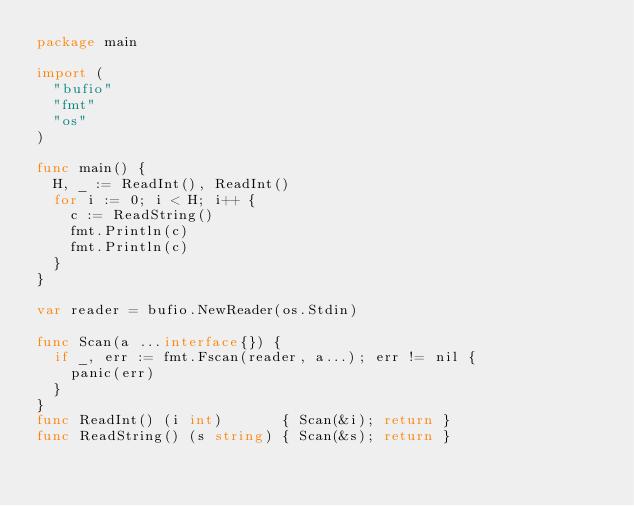<code> <loc_0><loc_0><loc_500><loc_500><_Go_>package main

import (
	"bufio"
	"fmt"
	"os"
)

func main() {
	H, _ := ReadInt(), ReadInt()
	for i := 0; i < H; i++ {
		c := ReadString()
		fmt.Println(c)
		fmt.Println(c)
	}
}

var reader = bufio.NewReader(os.Stdin)

func Scan(a ...interface{}) {
	if _, err := fmt.Fscan(reader, a...); err != nil {
		panic(err)
	}
}
func ReadInt() (i int)       { Scan(&i); return }
func ReadString() (s string) { Scan(&s); return }
</code> 